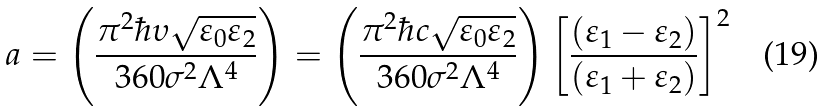<formula> <loc_0><loc_0><loc_500><loc_500>a = \left ( \frac { \pi ^ { 2 } \hbar { \upsilon } \sqrt { \varepsilon _ { 0 } \varepsilon _ { 2 } } } { 3 6 0 \sigma ^ { 2 } \Lambda ^ { 4 } } \right ) = \left ( \frac { \pi ^ { 2 } \hbar { c } \sqrt { \varepsilon _ { 0 } \varepsilon _ { 2 } } } { 3 6 0 \sigma ^ { 2 } \Lambda ^ { 4 } } \right ) \left [ \frac { ( \varepsilon _ { 1 } - \varepsilon _ { 2 } ) } { ( \varepsilon _ { 1 } + \varepsilon _ { 2 } ) } \right ] ^ { 2 }</formula> 